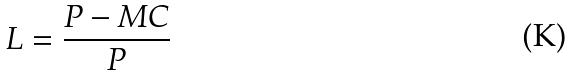Convert formula to latex. <formula><loc_0><loc_0><loc_500><loc_500>L = \frac { P - M C } { P }</formula> 